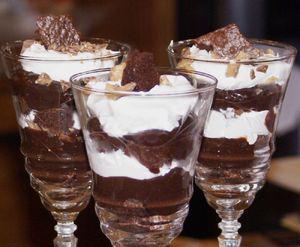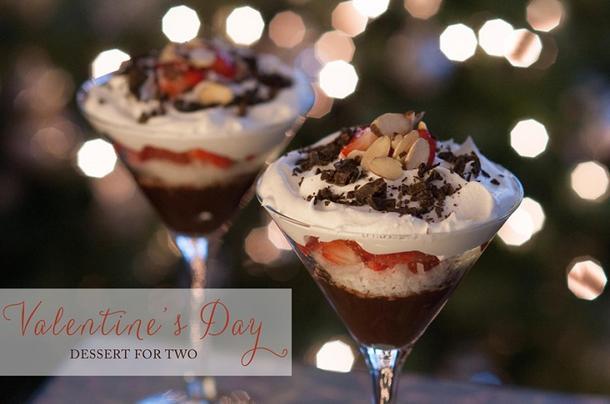The first image is the image on the left, the second image is the image on the right. Examine the images to the left and right. Is the description "An image shows a pair of martini-style glasses containing desserts that include a red layer surrounded by white cream, and a bottom chocolate layer." accurate? Answer yes or no. Yes. The first image is the image on the left, the second image is the image on the right. Examine the images to the left and right. Is the description "There are exactly four layered desserts in cups." accurate? Answer yes or no. No. 